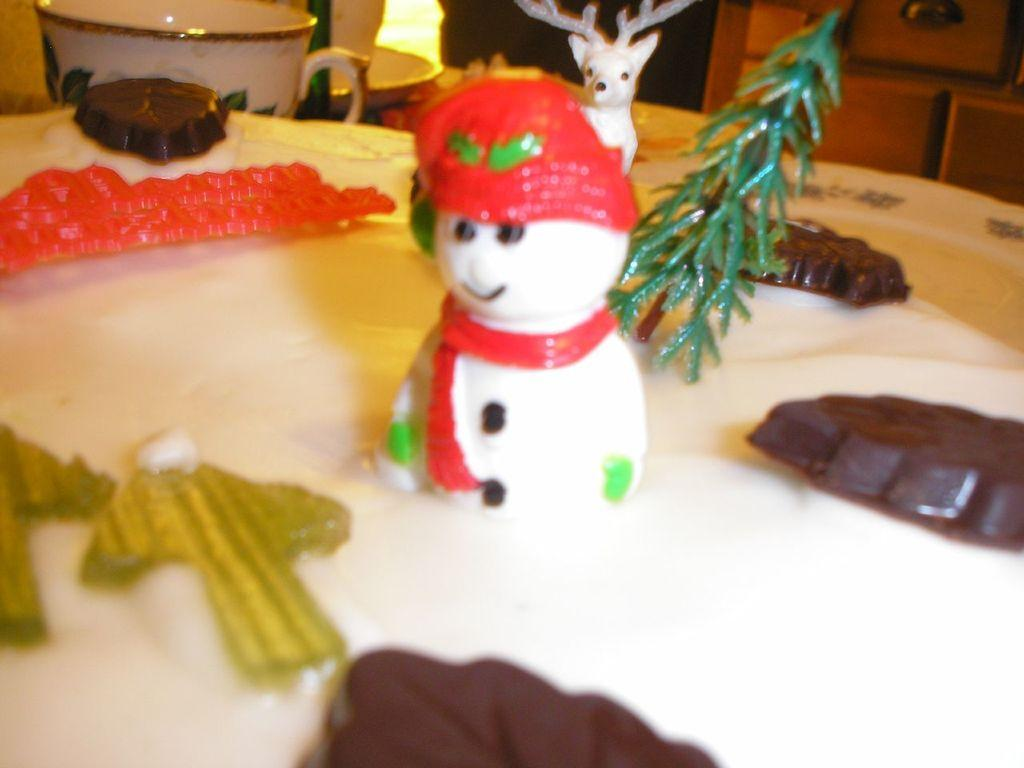What objects are in the front of the image? There are toys in the front of the image. Where is the cup located in the image? The cup is in the top left side of the image. What type of eggs are being served for dinner in the image? There is no mention of eggs or dinner in the image; it only features toys and a cup. 